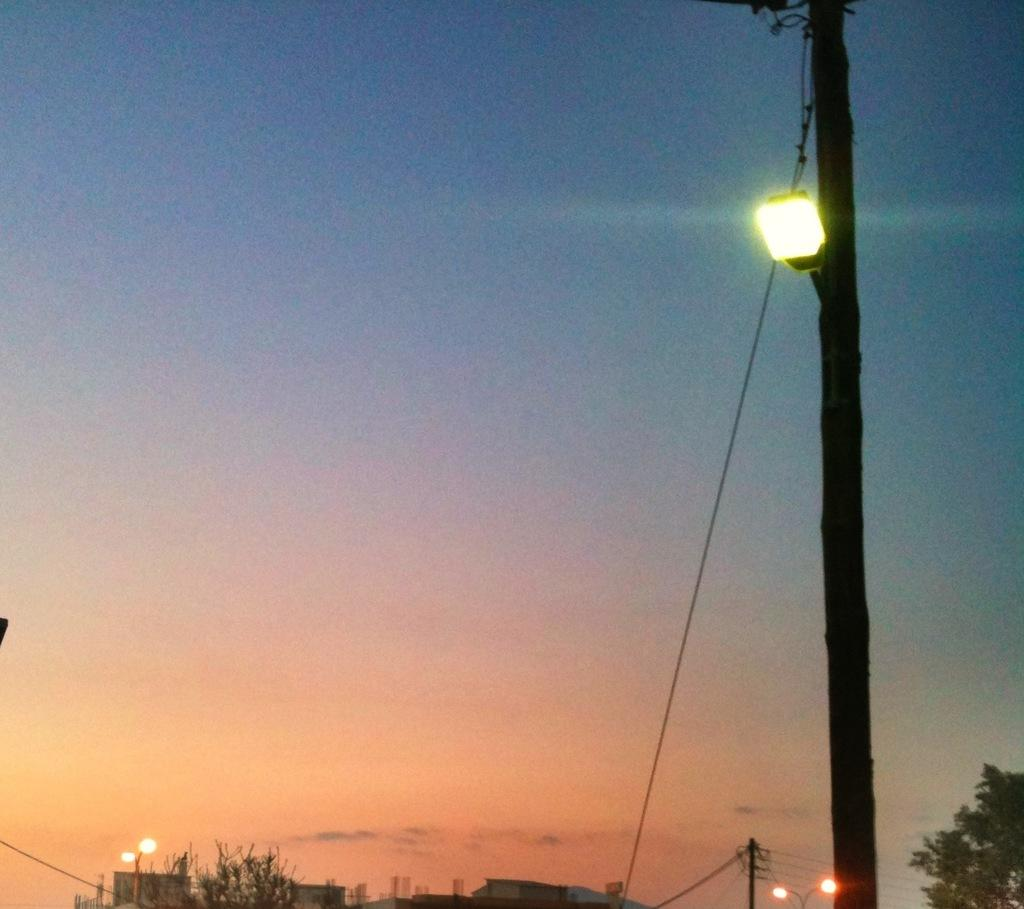What type of structures can be seen in the image? There are buildings in the image. What other natural elements are present in the image? There are trees in the image. What are the lights in the image used for? The lights in the image are likely used for illumination. What are the poles in the image used for? The poles in the image are likely used for supporting the lights or other objects. What can be seen in the background of the image? The sky is visible in the background of the image. What type of window can be seen in the image? There is no window present in the image. What is the border of the image made of? The border of the image is not visible in the image itself, as it is a property of the image file or medium. 